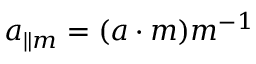<formula> <loc_0><loc_0><loc_500><loc_500>a _ { \| m } = ( a \cdot m ) m ^ { - 1 }</formula> 